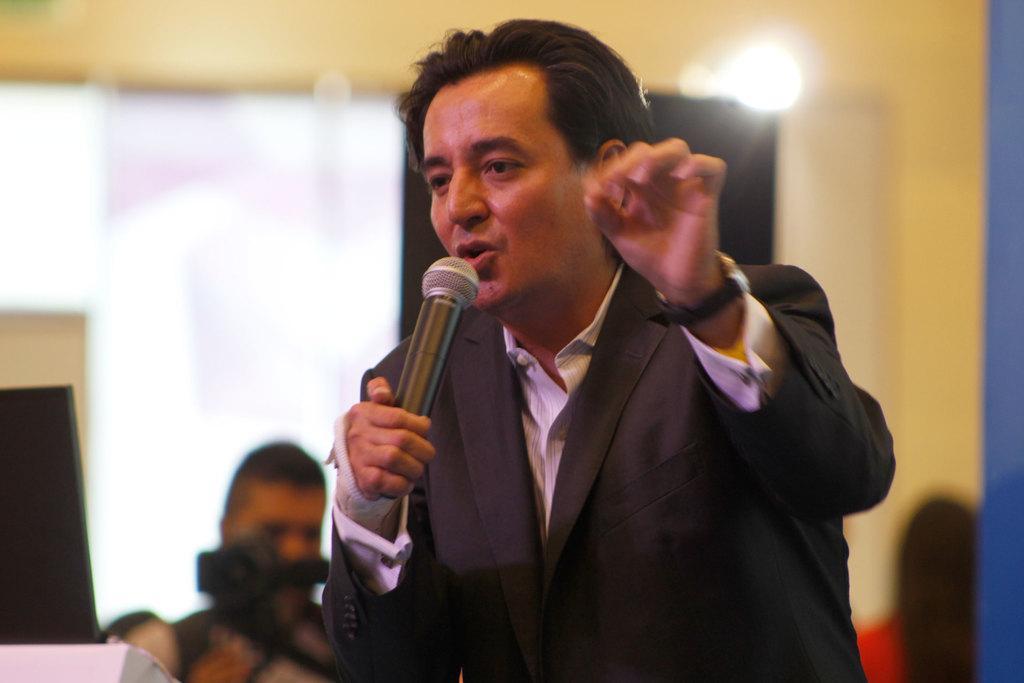Please provide a concise description of this image. This man wore suit and speaking in-front of mic. On top there is a light. Far a person is holding a camera. 